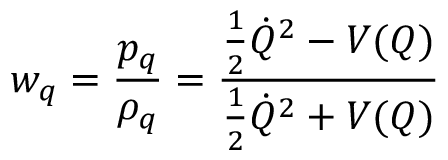Convert formula to latex. <formula><loc_0><loc_0><loc_500><loc_500>w _ { q } = { \frac { p _ { q } } { \rho _ { q } } } = { \frac { { \frac { 1 } { 2 } } { \dot { Q } } ^ { 2 } - V ( Q ) } { { \frac { 1 } { 2 } } { \dot { Q } } ^ { 2 } + V ( Q ) } }</formula> 